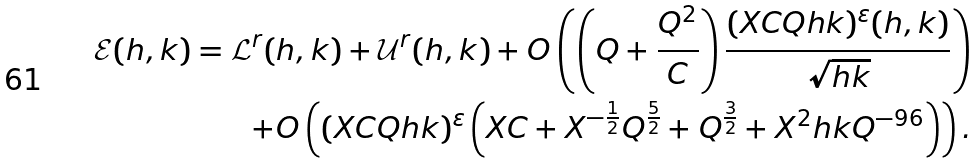<formula> <loc_0><loc_0><loc_500><loc_500>\mathcal { E } ( h , k ) = \mathcal { L } ^ { r } ( h , k ) + \mathcal { U } ^ { r } ( h , k ) + O \left ( \left ( Q + \frac { Q ^ { 2 } } { C } \right ) \frac { ( X C Q h k ) ^ { \varepsilon } ( h , k ) } { \sqrt { h k } } \right ) \\ + O \left ( ( X C Q h k ) ^ { \varepsilon } \left ( X C + X ^ { - \frac { 1 } { 2 } } Q ^ { \frac { 5 } { 2 } } + Q ^ { \frac { 3 } { 2 } } + X ^ { 2 } h k Q ^ { - 9 6 } \right ) \right ) .</formula> 